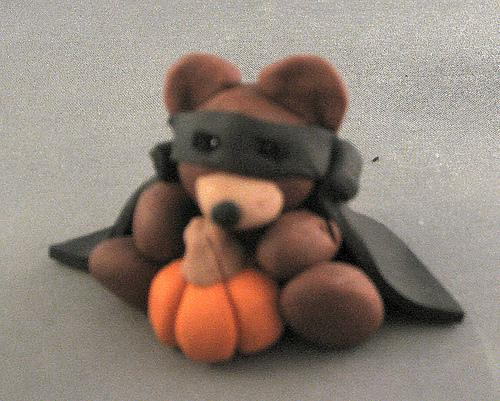Question: where is the doll?
Choices:
A. In the bedroom.
B. In the living room.
C. On the floor.
D. In the Solarium.
Answer with the letter. Answer: C Question: why is the doll in a mask?
Choices:
A. It came like that.
B. It's a costume.
C. Because it's fun.
D. The kid put it on.
Answer with the letter. Answer: B Question: who is in the photo?
Choices:
A. I am.
B. My aunt.
C. My uncle.
D. No one.
Answer with the letter. Answer: D Question: what color is the doll?
Choices:
A. White.
B. Peach.
C. Black.
D. Brown.
Answer with the letter. Answer: D Question: what color is the mask?
Choices:
A. Black.
B. Green.
C. White.
D. Brown.
Answer with the letter. Answer: A 